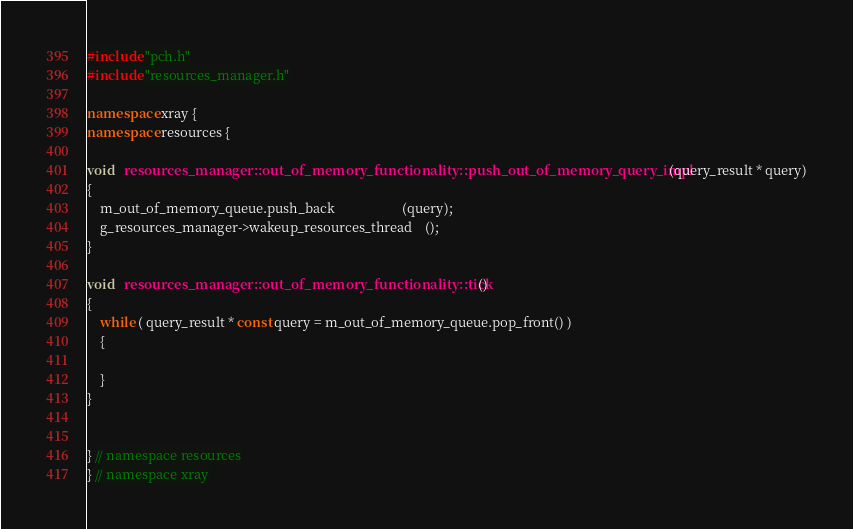<code> <loc_0><loc_0><loc_500><loc_500><_C++_>
#include "pch.h"
#include "resources_manager.h"

namespace xray {
namespace resources {

void   resources_manager::out_of_memory_functionality::push_out_of_memory_query_impl (query_result * query)
{
	m_out_of_memory_queue.push_back					(query);
	g_resources_manager->wakeup_resources_thread	();
}

void   resources_manager::out_of_memory_functionality::tick ()
{
	while ( query_result * const query = m_out_of_memory_queue.pop_front() )
	{

	}
}


} // namespace resources
} // namespace xray

</code> 